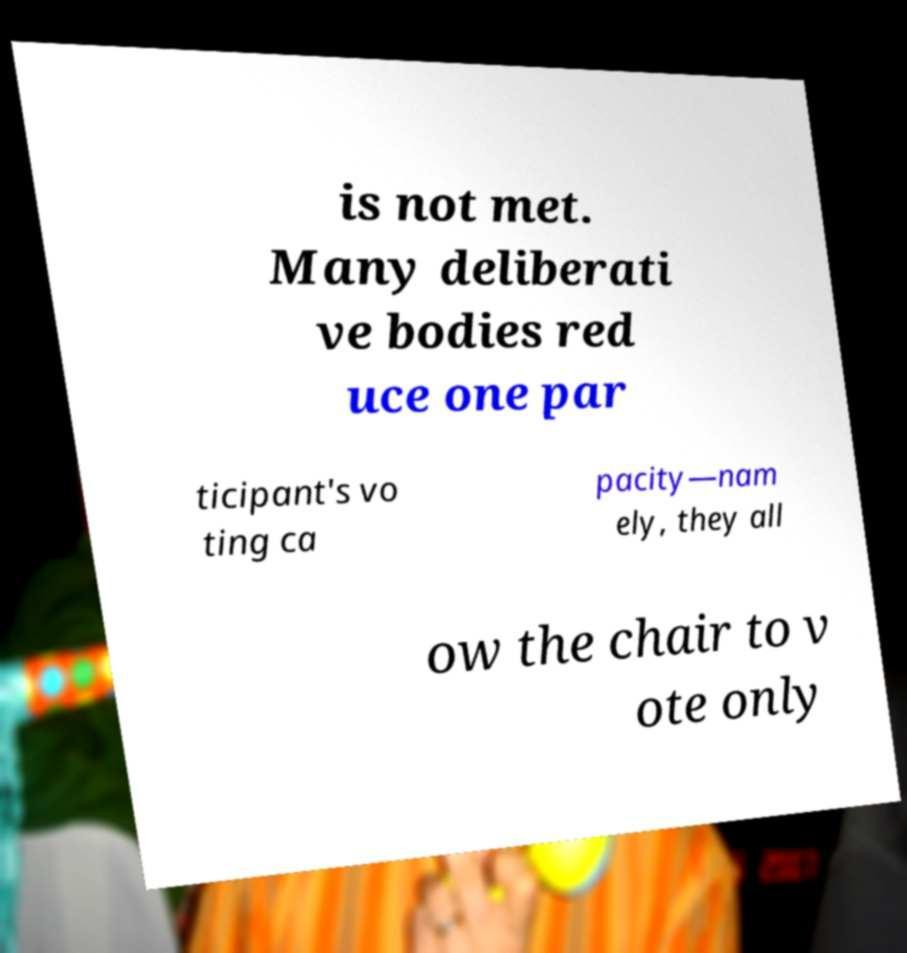I need the written content from this picture converted into text. Can you do that? is not met. Many deliberati ve bodies red uce one par ticipant's vo ting ca pacity—nam ely, they all ow the chair to v ote only 